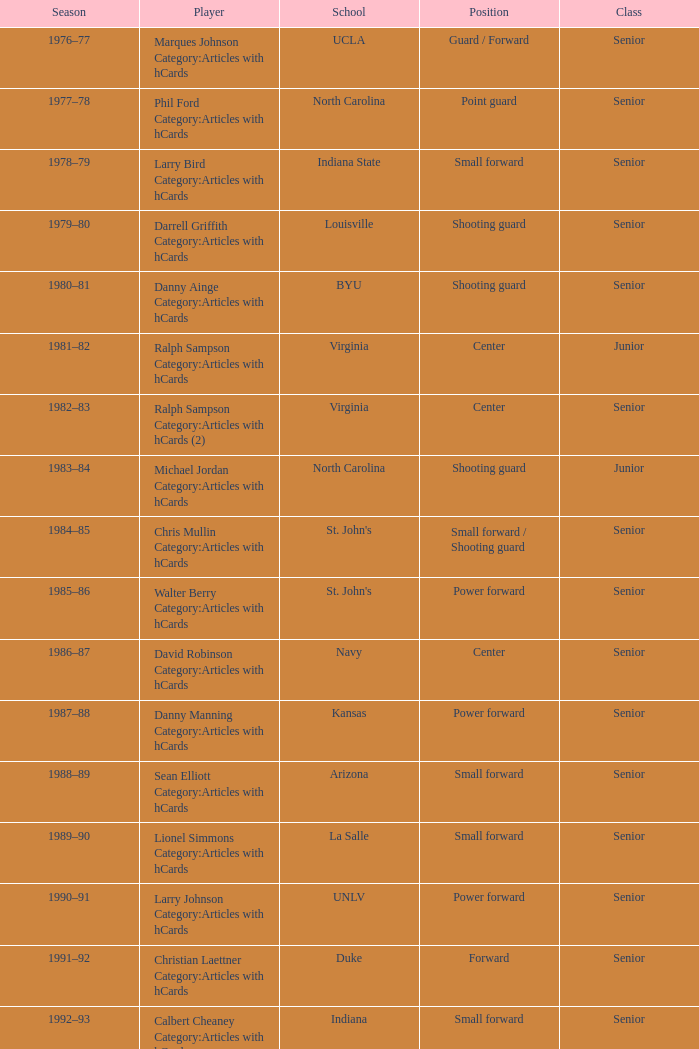Identify the role for the indiana state position. Small forward. 